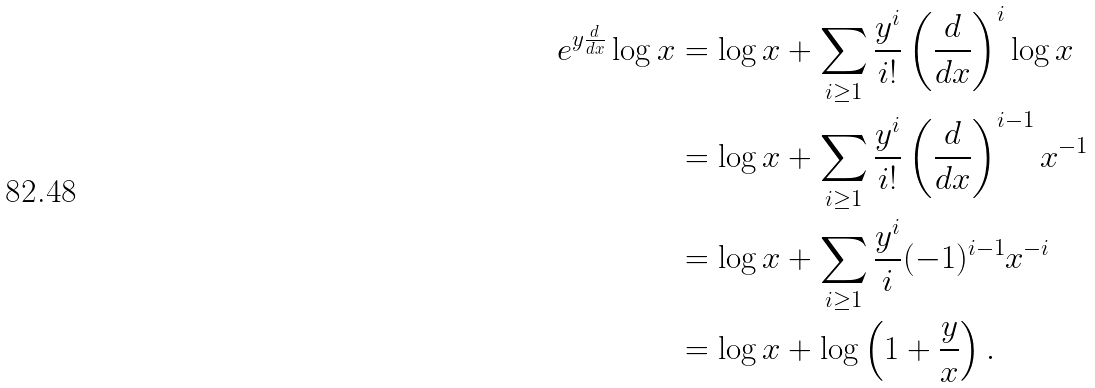<formula> <loc_0><loc_0><loc_500><loc_500>e ^ { y \frac { d } { d x } } \log x & = \log x + \sum _ { i \geq 1 } \frac { y ^ { i } } { i ! } \left ( \frac { d } { d x } \right ) ^ { i } \log x \\ & = \log x + \sum _ { i \geq 1 } \frac { y ^ { i } } { i ! } \left ( \frac { d } { d x } \right ) ^ { i - 1 } x ^ { - 1 } \\ & = \log x + \sum _ { i \geq 1 } \frac { y ^ { i } } { i } ( - 1 ) ^ { i - 1 } x ^ { - i } \\ & = \log x + \log \left ( 1 + \frac { y } { x } \right ) .</formula> 